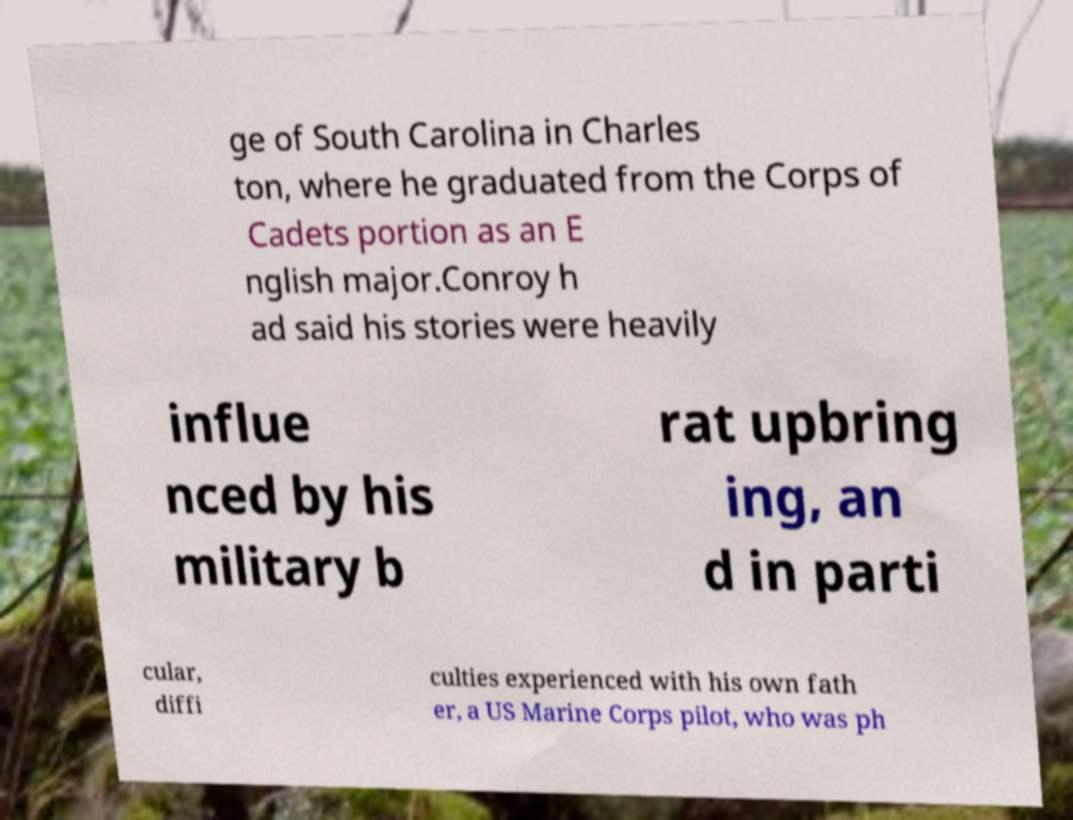I need the written content from this picture converted into text. Can you do that? ge of South Carolina in Charles ton, where he graduated from the Corps of Cadets portion as an E nglish major.Conroy h ad said his stories were heavily influe nced by his military b rat upbring ing, an d in parti cular, diffi culties experienced with his own fath er, a US Marine Corps pilot, who was ph 